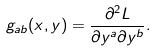Convert formula to latex. <formula><loc_0><loc_0><loc_500><loc_500>g _ { a b } ( x , y ) = \frac { \partial ^ { 2 } L } { \partial y ^ { a } \partial y ^ { b } } .</formula> 